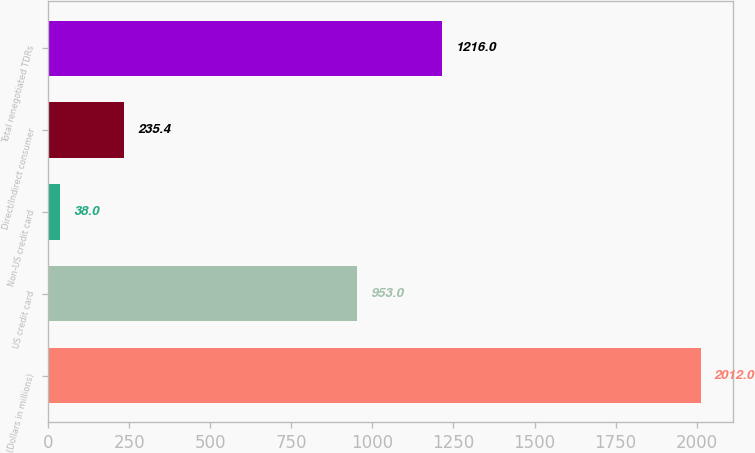<chart> <loc_0><loc_0><loc_500><loc_500><bar_chart><fcel>(Dollars in millions)<fcel>US credit card<fcel>Non-US credit card<fcel>Direct/Indirect consumer<fcel>Total renegotiated TDRs<nl><fcel>2012<fcel>953<fcel>38<fcel>235.4<fcel>1216<nl></chart> 